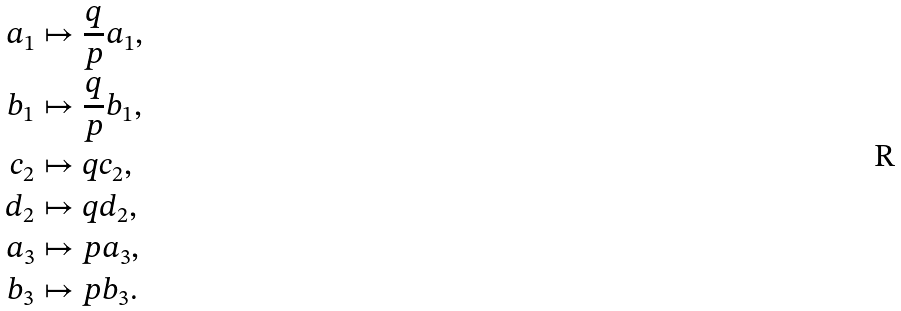<formula> <loc_0><loc_0><loc_500><loc_500>a _ { 1 } & \mapsto \frac { q } { p } a _ { 1 } , \\ b _ { 1 } & \mapsto \frac { q } { p } b _ { 1 } , \\ c _ { 2 } & \mapsto q c _ { 2 } , \\ d _ { 2 } & \mapsto q d _ { 2 } , \\ a _ { 3 } & \mapsto p a _ { 3 } , \\ b _ { 3 } & \mapsto p b _ { 3 } .</formula> 